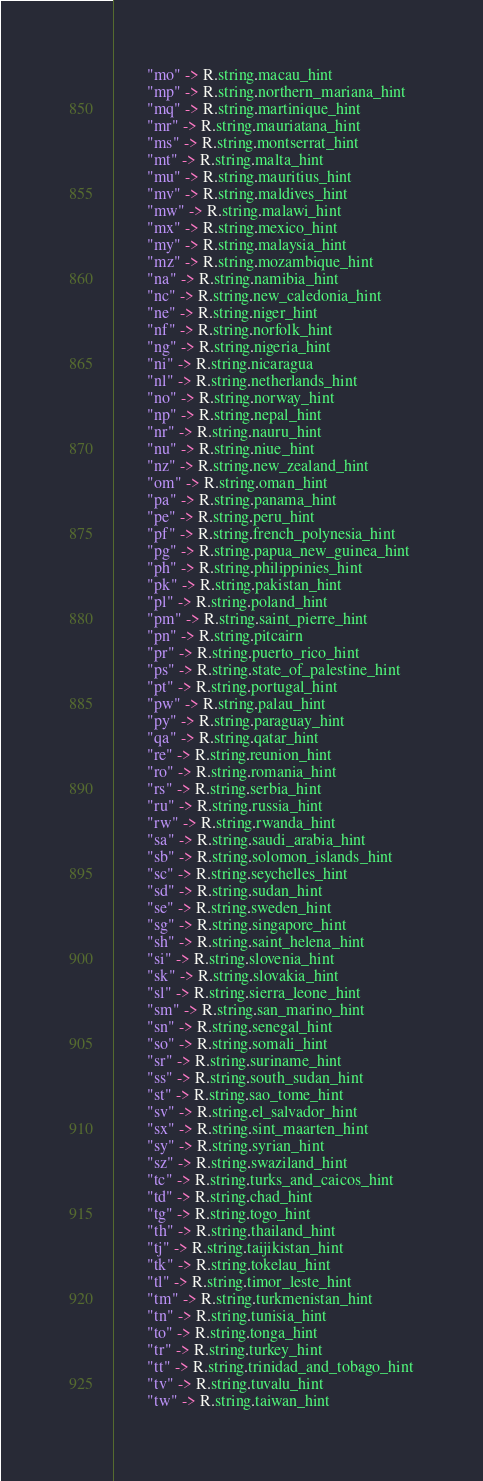<code> <loc_0><loc_0><loc_500><loc_500><_Kotlin_>        "mo" -> R.string.macau_hint
        "mp" -> R.string.northern_mariana_hint
        "mq" -> R.string.martinique_hint
        "mr" -> R.string.mauriatana_hint
        "ms" -> R.string.montserrat_hint
        "mt" -> R.string.malta_hint
        "mu" -> R.string.mauritius_hint
        "mv" -> R.string.maldives_hint
        "mw" -> R.string.malawi_hint
        "mx" -> R.string.mexico_hint
        "my" -> R.string.malaysia_hint
        "mz" -> R.string.mozambique_hint
        "na" -> R.string.namibia_hint
        "nc" -> R.string.new_caledonia_hint
        "ne" -> R.string.niger_hint
        "nf" -> R.string.norfolk_hint
        "ng" -> R.string.nigeria_hint
        "ni" -> R.string.nicaragua
        "nl" -> R.string.netherlands_hint
        "no" -> R.string.norway_hint
        "np" -> R.string.nepal_hint
        "nr" -> R.string.nauru_hint
        "nu" -> R.string.niue_hint
        "nz" -> R.string.new_zealand_hint
        "om" -> R.string.oman_hint
        "pa" -> R.string.panama_hint
        "pe" -> R.string.peru_hint
        "pf" -> R.string.french_polynesia_hint
        "pg" -> R.string.papua_new_guinea_hint
        "ph" -> R.string.philippinies_hint
        "pk" -> R.string.pakistan_hint
        "pl" -> R.string.poland_hint
        "pm" -> R.string.saint_pierre_hint
        "pn" -> R.string.pitcairn
        "pr" -> R.string.puerto_rico_hint
        "ps" -> R.string.state_of_palestine_hint
        "pt" -> R.string.portugal_hint
        "pw" -> R.string.palau_hint
        "py" -> R.string.paraguay_hint
        "qa" -> R.string.qatar_hint
        "re" -> R.string.reunion_hint
        "ro" -> R.string.romania_hint
        "rs" -> R.string.serbia_hint
        "ru" -> R.string.russia_hint
        "rw" -> R.string.rwanda_hint
        "sa" -> R.string.saudi_arabia_hint
        "sb" -> R.string.solomon_islands_hint
        "sc" -> R.string.seychelles_hint
        "sd" -> R.string.sudan_hint
        "se" -> R.string.sweden_hint
        "sg" -> R.string.singapore_hint
        "sh" -> R.string.saint_helena_hint
        "si" -> R.string.slovenia_hint
        "sk" -> R.string.slovakia_hint
        "sl" -> R.string.sierra_leone_hint
        "sm" -> R.string.san_marino_hint
        "sn" -> R.string.senegal_hint
        "so" -> R.string.somali_hint
        "sr" -> R.string.suriname_hint
        "ss" -> R.string.south_sudan_hint
        "st" -> R.string.sao_tome_hint
        "sv" -> R.string.el_salvador_hint
        "sx" -> R.string.sint_maarten_hint
        "sy" -> R.string.syrian_hint
        "sz" -> R.string.swaziland_hint
        "tc" -> R.string.turks_and_caicos_hint
        "td" -> R.string.chad_hint
        "tg" -> R.string.togo_hint
        "th" -> R.string.thailand_hint
        "tj" -> R.string.taijikistan_hint
        "tk" -> R.string.tokelau_hint
        "tl" -> R.string.timor_leste_hint
        "tm" -> R.string.turkmenistan_hint
        "tn" -> R.string.tunisia_hint
        "to" -> R.string.tonga_hint
        "tr" -> R.string.turkey_hint
        "tt" -> R.string.trinidad_and_tobago_hint
        "tv" -> R.string.tuvalu_hint
        "tw" -> R.string.taiwan_hint</code> 